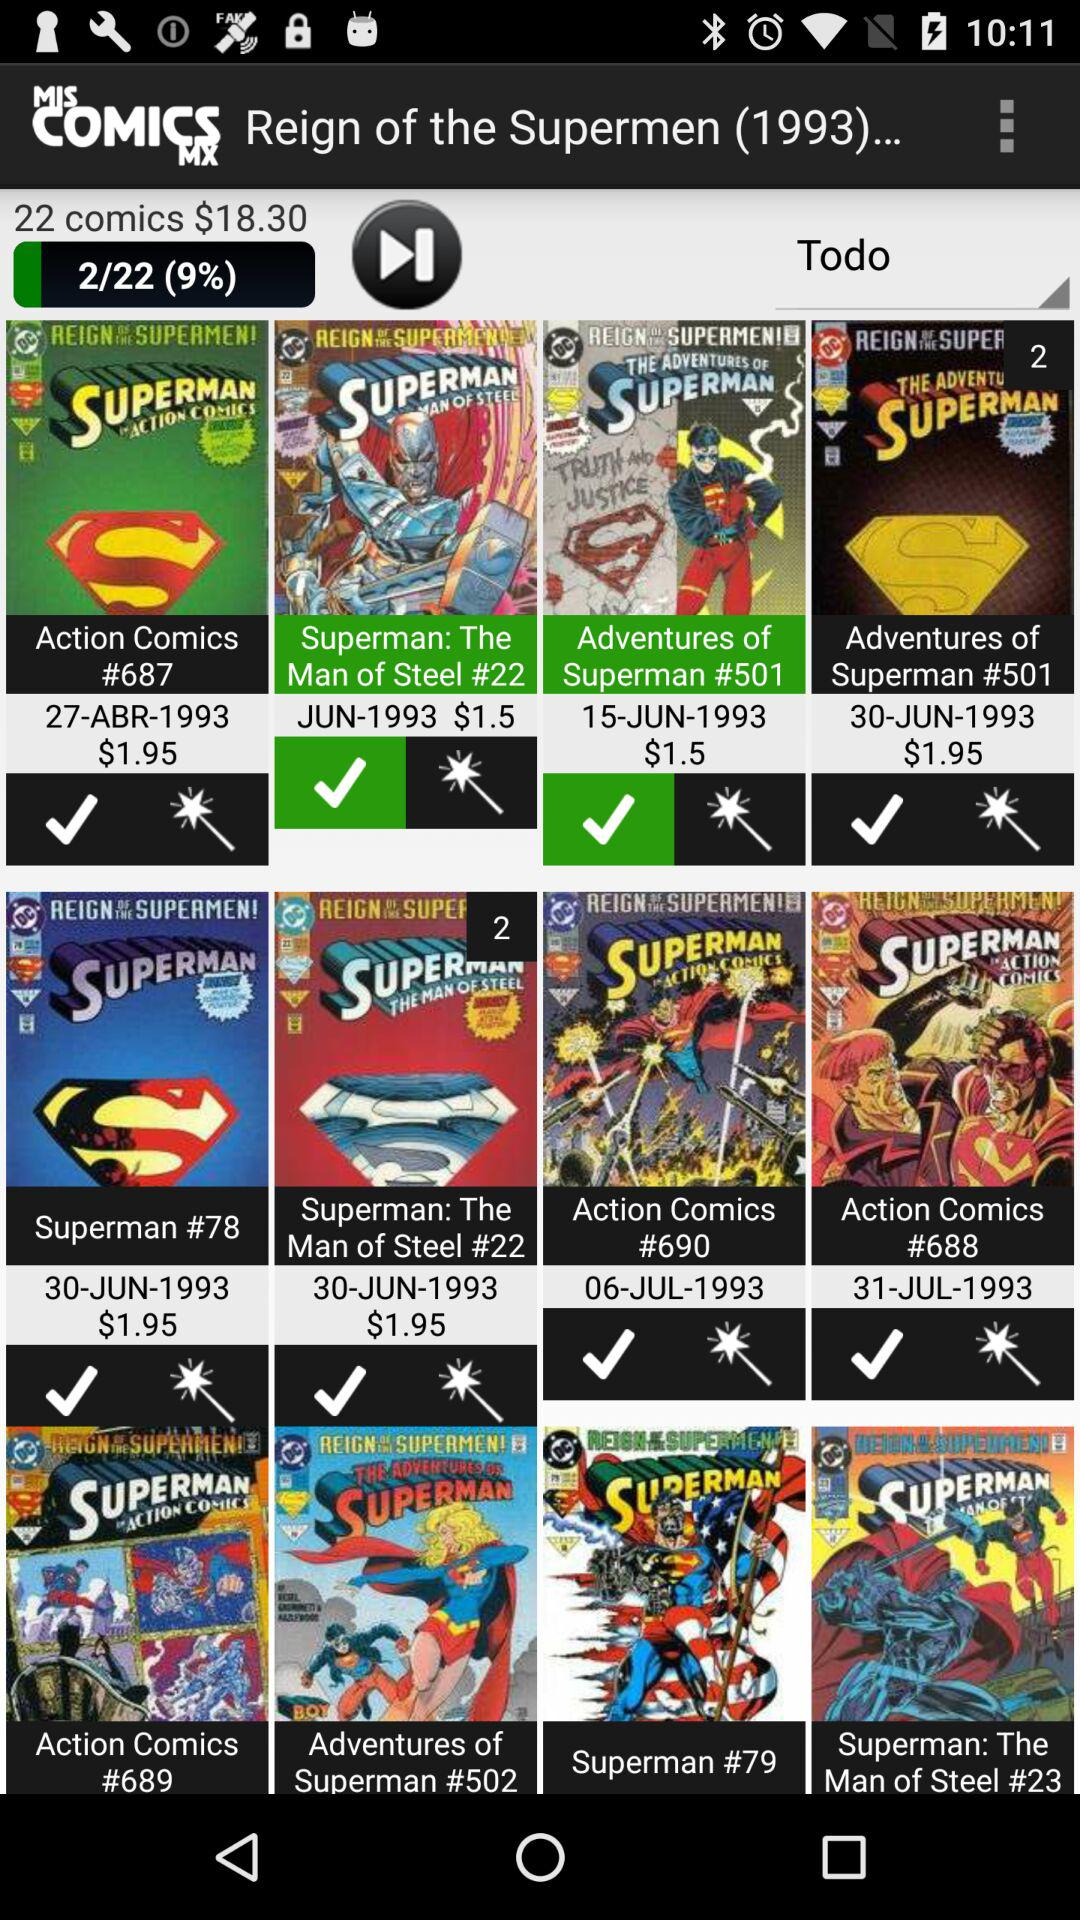What is the published year of the "Reign of the Superman"? The published year of the "Reign of the Superman" is 1993. 